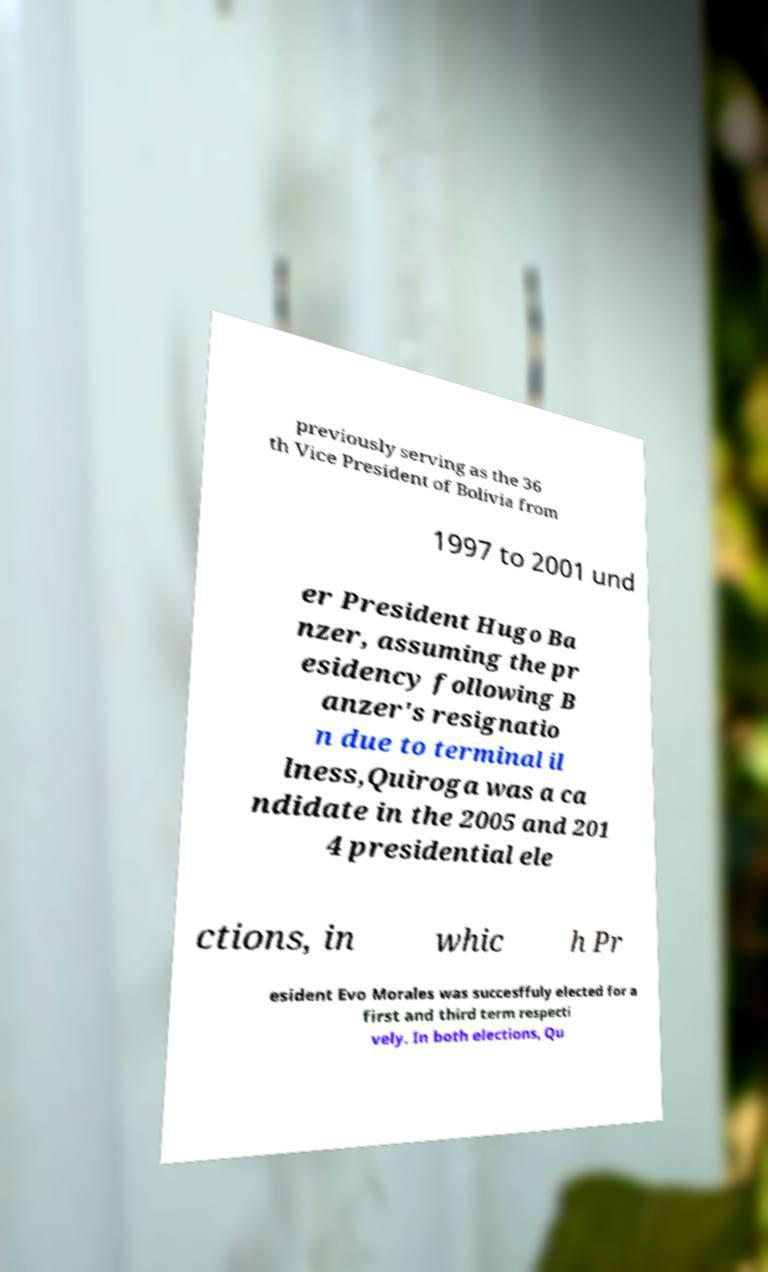Please read and relay the text visible in this image. What does it say? previously serving as the 36 th Vice President of Bolivia from 1997 to 2001 und er President Hugo Ba nzer, assuming the pr esidency following B anzer's resignatio n due to terminal il lness,Quiroga was a ca ndidate in the 2005 and 201 4 presidential ele ctions, in whic h Pr esident Evo Morales was succesffuly elected for a first and third term respecti vely. In both elections, Qu 